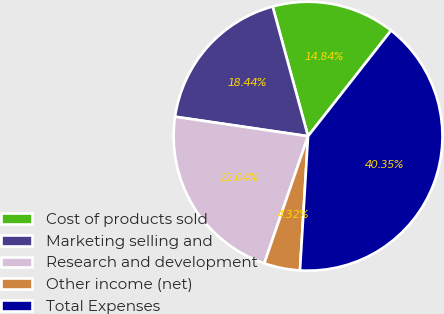Convert chart. <chart><loc_0><loc_0><loc_500><loc_500><pie_chart><fcel>Cost of products sold<fcel>Marketing selling and<fcel>Research and development<fcel>Other income (net)<fcel>Total Expenses<nl><fcel>14.84%<fcel>18.44%<fcel>22.04%<fcel>4.32%<fcel>40.35%<nl></chart> 